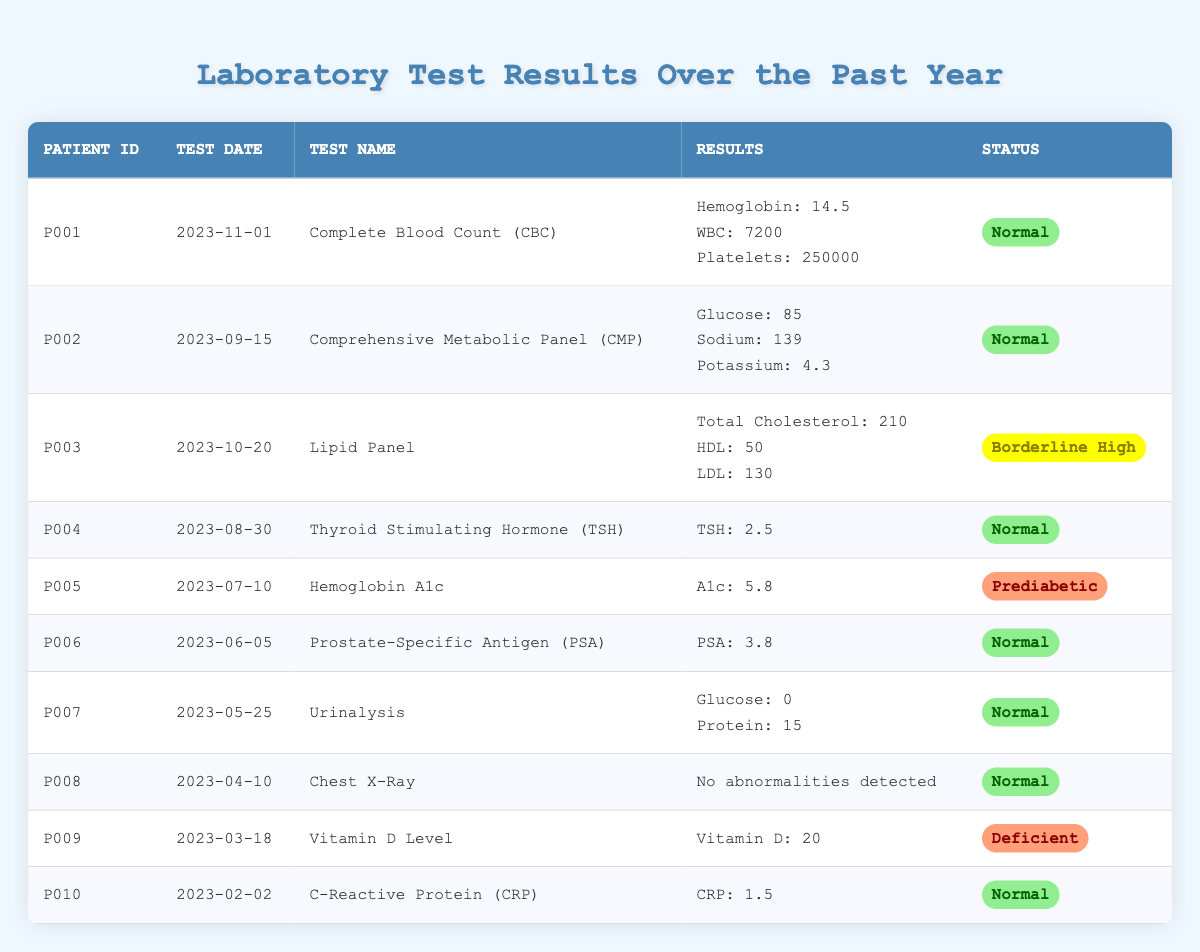What is the status of the lab test for Patient P001? The status for Patient P001's test can be found in the last column of their row in the table. It is labeled as "Normal."
Answer: Normal What test did Patient P005 undergo? By examining the second column of Patient P005's row, the test name listed is "Hemoglobin A1c."
Answer: Hemoglobin A1c How many tests have a status of "Normal"? To find this, I will count the number of rows where the status is labeled "Normal." There are 7 rows with this status in the table: P001, P002, P004, P006, P007, P008, and P010.
Answer: 7 What is the highest recorded glucose level in the tests? From the table, the only test with glucose data is from Patient P002, whose glucose level is 85. There are no other entries for glucose in the other tests provided.
Answer: 85 Is there any lab test for which the patient has a "Deficient" status? We can check the status column for any entries that indicate "Deficient." There is one entry for Patient P009 labeled as "Deficient." Therefore, the answer is yes.
Answer: Yes What is the average hemoglobin level from the tests where this measurement is available? The hemoglobin levels are for Patient P001 (14.5) and Patient P005 (not applicable as it's an A1c test). Therefore, there's only one valid hemoglobin level. The average is simply 14.5 since there is one value.
Answer: 14.5 Which patient had a test status labeled "Borderline High"? Looking at the status column, Patient P003's test is labeled "Borderline High," indicating that they are the only patient with this status.
Answer: P003 How many patients showed prediabetic or borderline high results? Combining the entries for prediabetic (Patient P005) and borderline high (Patient P003), we have two patients total: P003 and P005.
Answer: 2 What test had the earliest date in the table, and what was the status? The earliest date in the table is for Patient P010 on February 2, 2023, and the corresponding status is "Normal."
Answer: C-Reactive Protein (CRP), Normal 